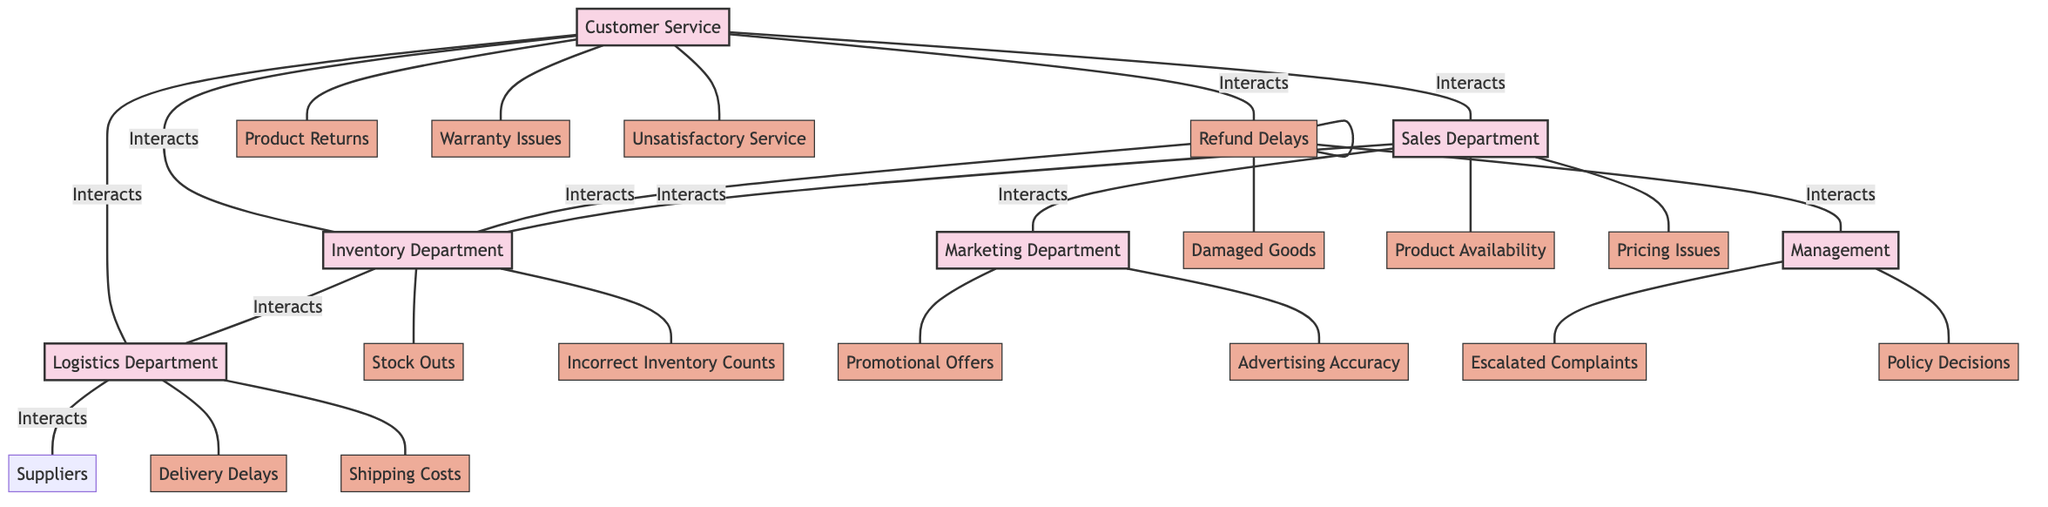What is the total number of departments in the diagram? The diagram lists seven departments: Customer Service, Returns Department, Sales Department, Inventory Department, Logistics Department, Marketing Department, and Management. Therefore, by counting these names, the total number of departments is seven.
Answer: Seven Which department interacts with both the Sales Department and the Inventory Department? By examining the interactions of the Sales Department, we see that it interacts with Customer Service, Marketing Department, and Inventory Department. Meanwhile, the Inventory Department interacts with Customer Service, Sales Department, Returns Department, and Logistics Department. The shared entity between these two is indeed the Inventory Department.
Answer: Inventory Department What is one customer concern linked to the Returns Department? Looking into the customer concerns related to the Returns Department, we find that "Refund Delays" and "Damaged Goods" are listed. Therefore, either could be a valid answer. However, since we only need one, we can choose the first mentioned concern which is Refund Delays.
Answer: Refund Delays Which two departments are directly connected to the Logistics Department? The Logistics Department interacts with the Customer Service, Inventory Department, and Suppliers. Among these, the two departments that interact directly with Logistics without involving Suppliers are Customer Service and Inventory Department.
Answer: Customer Service, Inventory Department How many customer concerns are associated with the Marketing Department? The Marketing Department has two customer concerns listed, which are "Promotional Offers" and "Advertising Accuracy." Counting these concerns gives us the total as two.
Answer: Two What would be the best department to contact regarding product stock issues? The Inventory Department is responsible for stock-related concerns, including "Stock Outs" and "Incorrect Inventory Counts." Since these troubles align perfectly with stock issues, reaching out to the Inventory Department would be the most appropriate action.
Answer: Inventory Department How many total customer concerns are listed in the diagram? By examining the customer concerns associated with each department, we can tally them up: Customer Service has 3, Returns Department has 2, Sales Department has 2, Inventory Department has 2, Logistics Department has 2, Marketing Department has 2, and Management has 2. Adding them together gives a total of 15 customer concerns.
Answer: Fifteen Which department is responsible for handling escalated complaints? According to the diagram, Management is associated with the customer concern of "Escalated Complaints," indicating that they handle these types of issues directly.
Answer: Management 